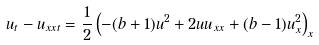Convert formula to latex. <formula><loc_0><loc_0><loc_500><loc_500>u _ { t } - u _ { x x t } = \frac { 1 } { 2 } \left ( - ( b + 1 ) u ^ { 2 } + 2 u u _ { x x } + ( b - 1 ) u _ { x } ^ { 2 } \right ) _ { x }</formula> 